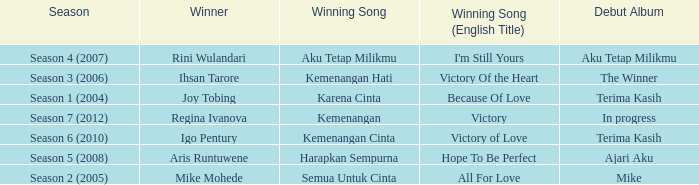Who won with the song kemenangan cinta? Igo Pentury. 